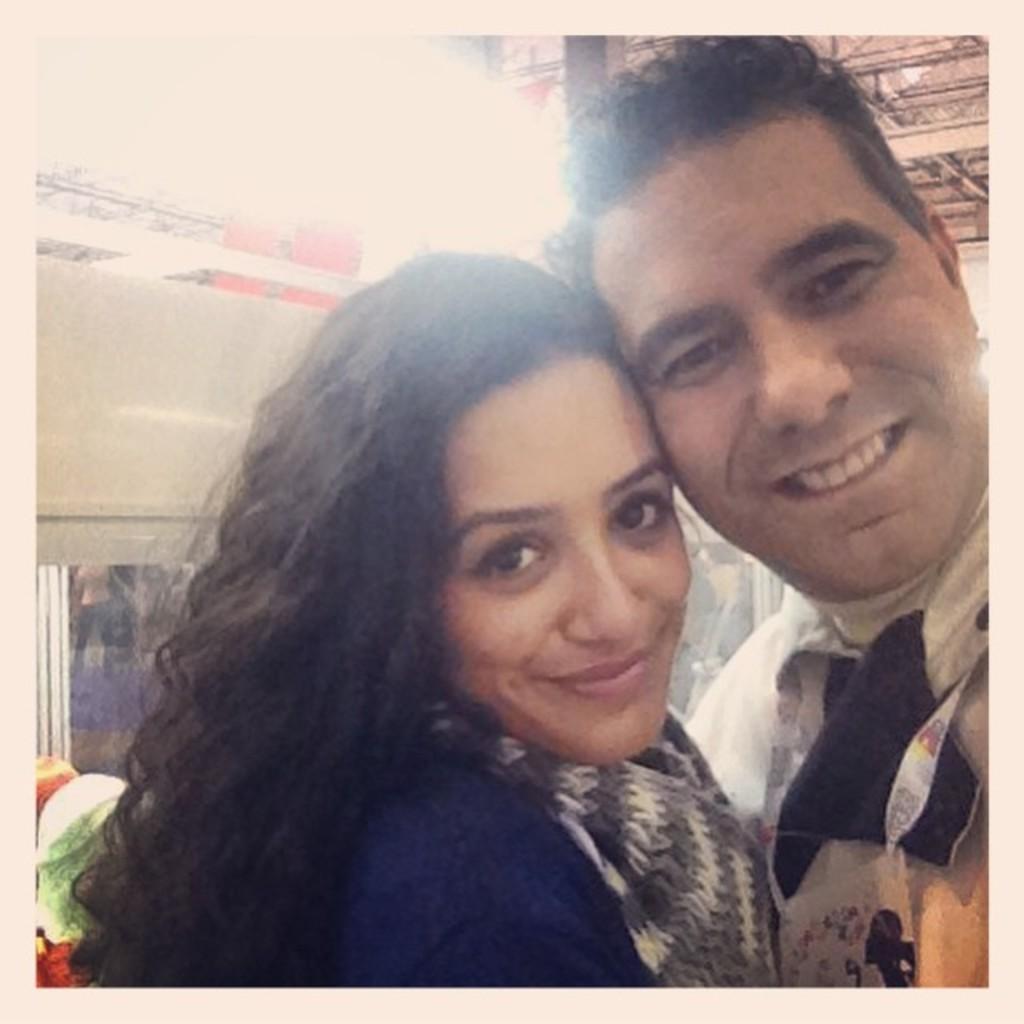Describe this image in one or two sentences. In this image we can see two persons. In the background, we can see a wall with a window and a person is standing and the shed. 